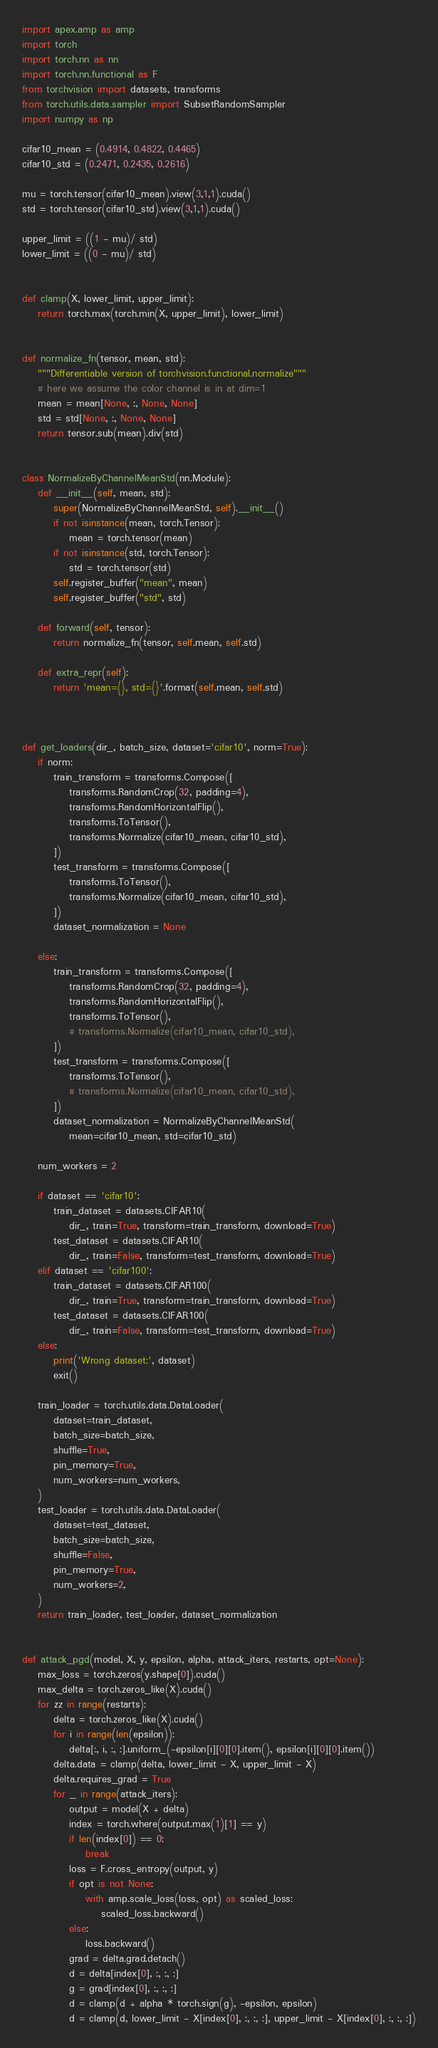Convert code to text. <code><loc_0><loc_0><loc_500><loc_500><_Python_>import apex.amp as amp
import torch
import torch.nn as nn
import torch.nn.functional as F
from torchvision import datasets, transforms
from torch.utils.data.sampler import SubsetRandomSampler
import numpy as np

cifar10_mean = (0.4914, 0.4822, 0.4465)
cifar10_std = (0.2471, 0.2435, 0.2616)

mu = torch.tensor(cifar10_mean).view(3,1,1).cuda()
std = torch.tensor(cifar10_std).view(3,1,1).cuda()

upper_limit = ((1 - mu)/ std)
lower_limit = ((0 - mu)/ std)


def clamp(X, lower_limit, upper_limit):
    return torch.max(torch.min(X, upper_limit), lower_limit)


def normalize_fn(tensor, mean, std):
    """Differentiable version of torchvision.functional.normalize"""
    # here we assume the color channel is in at dim=1
    mean = mean[None, :, None, None]
    std = std[None, :, None, None]
    return tensor.sub(mean).div(std)


class NormalizeByChannelMeanStd(nn.Module):
    def __init__(self, mean, std):
        super(NormalizeByChannelMeanStd, self).__init__()
        if not isinstance(mean, torch.Tensor):
            mean = torch.tensor(mean)
        if not isinstance(std, torch.Tensor):
            std = torch.tensor(std)
        self.register_buffer("mean", mean)
        self.register_buffer("std", std)

    def forward(self, tensor):
        return normalize_fn(tensor, self.mean, self.std)

    def extra_repr(self):
        return 'mean={}, std={}'.format(self.mean, self.std)



def get_loaders(dir_, batch_size, dataset='cifar10', norm=True):
    if norm:
        train_transform = transforms.Compose([
            transforms.RandomCrop(32, padding=4),
            transforms.RandomHorizontalFlip(),
            transforms.ToTensor(),
            transforms.Normalize(cifar10_mean, cifar10_std),
        ])
        test_transform = transforms.Compose([
            transforms.ToTensor(),
            transforms.Normalize(cifar10_mean, cifar10_std),
        ])
        dataset_normalization = None

    else:
        train_transform = transforms.Compose([
            transforms.RandomCrop(32, padding=4),
            transforms.RandomHorizontalFlip(),
            transforms.ToTensor(),
            # transforms.Normalize(cifar10_mean, cifar10_std),
        ])
        test_transform = transforms.Compose([
            transforms.ToTensor(),
            # transforms.Normalize(cifar10_mean, cifar10_std),
        ])
        dataset_normalization = NormalizeByChannelMeanStd(
            mean=cifar10_mean, std=cifar10_std)

    num_workers = 2
    
    if dataset == 'cifar10':
        train_dataset = datasets.CIFAR10(
            dir_, train=True, transform=train_transform, download=True)
        test_dataset = datasets.CIFAR10(
            dir_, train=False, transform=test_transform, download=True)
    elif dataset == 'cifar100':
        train_dataset = datasets.CIFAR100(
            dir_, train=True, transform=train_transform, download=True)
        test_dataset = datasets.CIFAR100(
            dir_, train=False, transform=test_transform, download=True)
    else:
        print('Wrong dataset:', dataset)
        exit()

    train_loader = torch.utils.data.DataLoader(
        dataset=train_dataset,
        batch_size=batch_size,
        shuffle=True,
        pin_memory=True,
        num_workers=num_workers,
    )
    test_loader = torch.utils.data.DataLoader(
        dataset=test_dataset,
        batch_size=batch_size,
        shuffle=False,
        pin_memory=True,
        num_workers=2,
    )
    return train_loader, test_loader, dataset_normalization


def attack_pgd(model, X, y, epsilon, alpha, attack_iters, restarts, opt=None):
    max_loss = torch.zeros(y.shape[0]).cuda()
    max_delta = torch.zeros_like(X).cuda()
    for zz in range(restarts):
        delta = torch.zeros_like(X).cuda()
        for i in range(len(epsilon)):
            delta[:, i, :, :].uniform_(-epsilon[i][0][0].item(), epsilon[i][0][0].item())
        delta.data = clamp(delta, lower_limit - X, upper_limit - X)
        delta.requires_grad = True
        for _ in range(attack_iters):
            output = model(X + delta)
            index = torch.where(output.max(1)[1] == y)
            if len(index[0]) == 0:
                break
            loss = F.cross_entropy(output, y)
            if opt is not None:
                with amp.scale_loss(loss, opt) as scaled_loss:
                    scaled_loss.backward()
            else:
                loss.backward()
            grad = delta.grad.detach()
            d = delta[index[0], :, :, :]
            g = grad[index[0], :, :, :]
            d = clamp(d + alpha * torch.sign(g), -epsilon, epsilon)
            d = clamp(d, lower_limit - X[index[0], :, :, :], upper_limit - X[index[0], :, :, :])</code> 